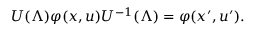Convert formula to latex. <formula><loc_0><loc_0><loc_500><loc_500>U ( \Lambda ) \varphi ( x , u ) U ^ { - 1 } ( \Lambda ) = \varphi ( x ^ { \prime } , u ^ { \prime } ) .</formula> 